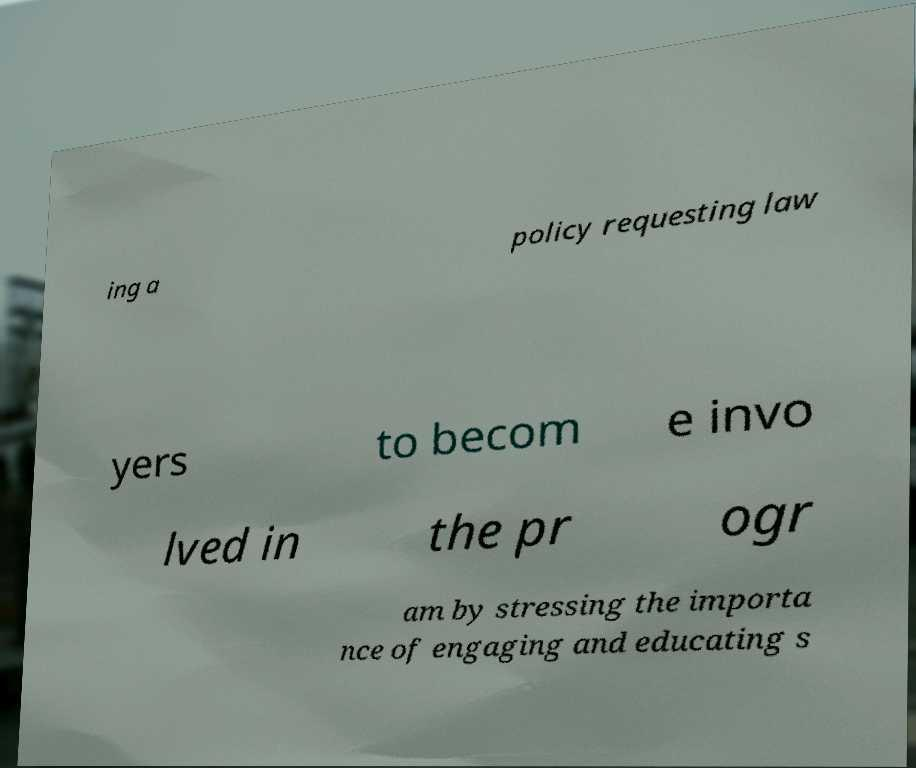Could you extract and type out the text from this image? ing a policy requesting law yers to becom e invo lved in the pr ogr am by stressing the importa nce of engaging and educating s 